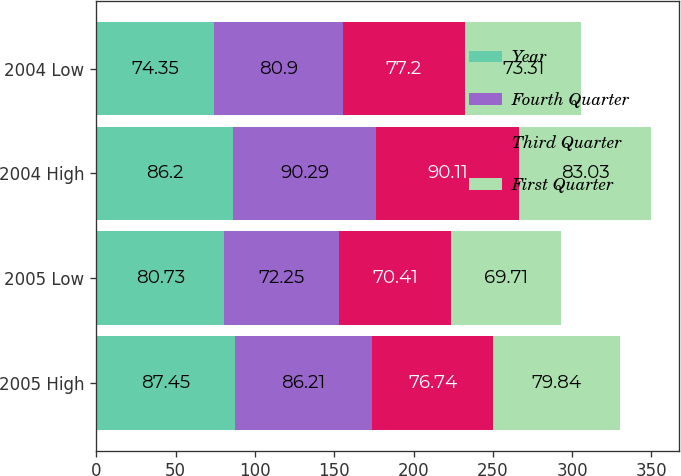Convert chart. <chart><loc_0><loc_0><loc_500><loc_500><stacked_bar_chart><ecel><fcel>2005 High<fcel>2005 Low<fcel>2004 High<fcel>2004 Low<nl><fcel>Year<fcel>87.45<fcel>80.73<fcel>86.2<fcel>74.35<nl><fcel>Fourth Quarter<fcel>86.21<fcel>72.25<fcel>90.29<fcel>80.9<nl><fcel>Third Quarter<fcel>76.74<fcel>70.41<fcel>90.11<fcel>77.2<nl><fcel>First Quarter<fcel>79.84<fcel>69.71<fcel>83.03<fcel>73.31<nl></chart> 